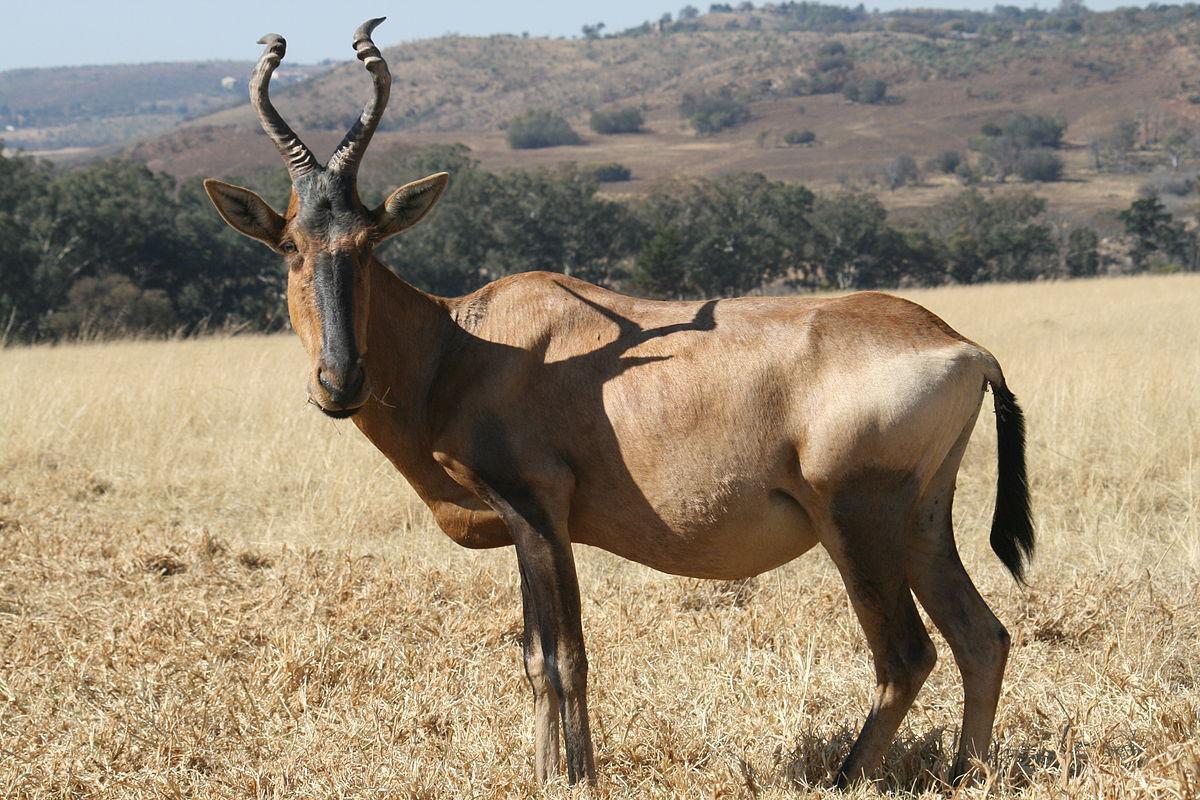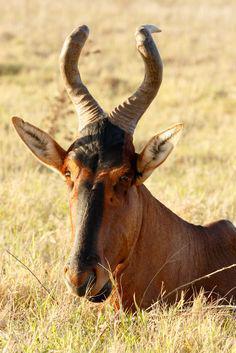The first image is the image on the left, the second image is the image on the right. Examine the images to the left and right. Is the description "There are more than two horned animals in the grassy field." accurate? Answer yes or no. No. 